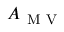<formula> <loc_0><loc_0><loc_500><loc_500>A _ { M V }</formula> 